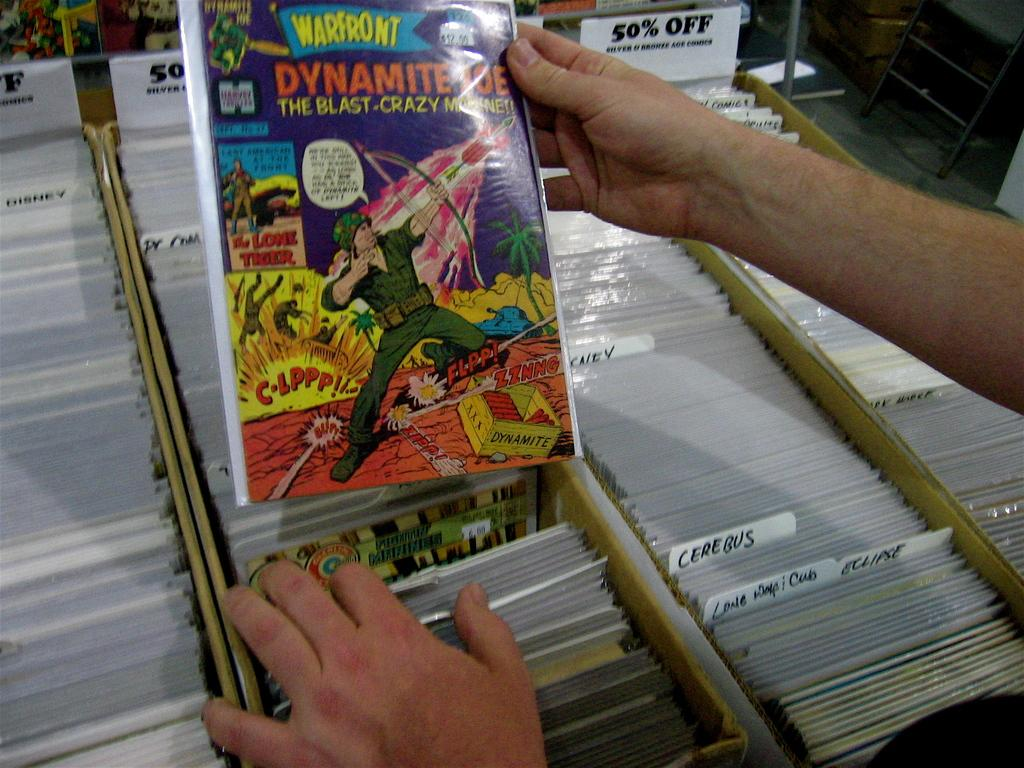<image>
Render a clear and concise summary of the photo. a Dynamite comic book with many others around it 